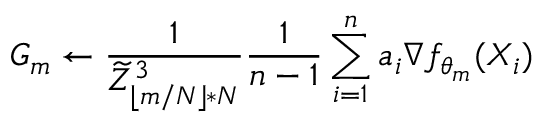Convert formula to latex. <formula><loc_0><loc_0><loc_500><loc_500>G _ { m } \gets \frac { 1 } { \widetilde { Z } _ { \lfloor m / N \rfloor * N } ^ { 3 } } \frac { 1 } n - 1 } \sum _ { i = 1 } ^ { n } a _ { i } \nabla f _ { \theta _ { m } } ( X _ { i } )</formula> 